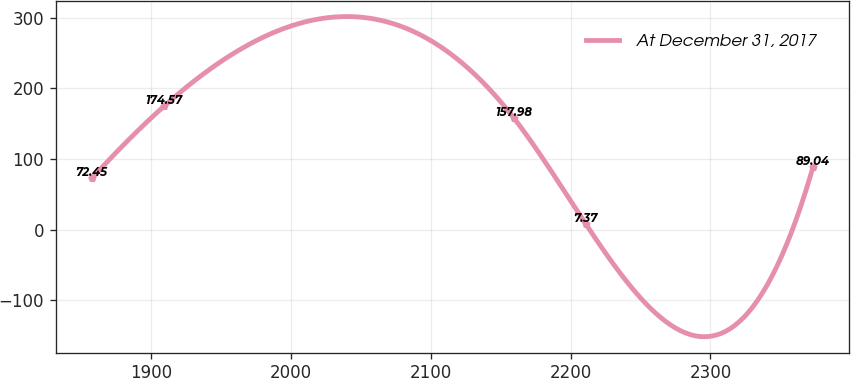Convert chart. <chart><loc_0><loc_0><loc_500><loc_500><line_chart><ecel><fcel>At December 31, 2017<nl><fcel>1857.45<fcel>72.45<nl><fcel>1909.04<fcel>174.57<nl><fcel>2159.43<fcel>157.98<nl><fcel>2211.02<fcel>7.37<nl><fcel>2373.39<fcel>89.04<nl></chart> 